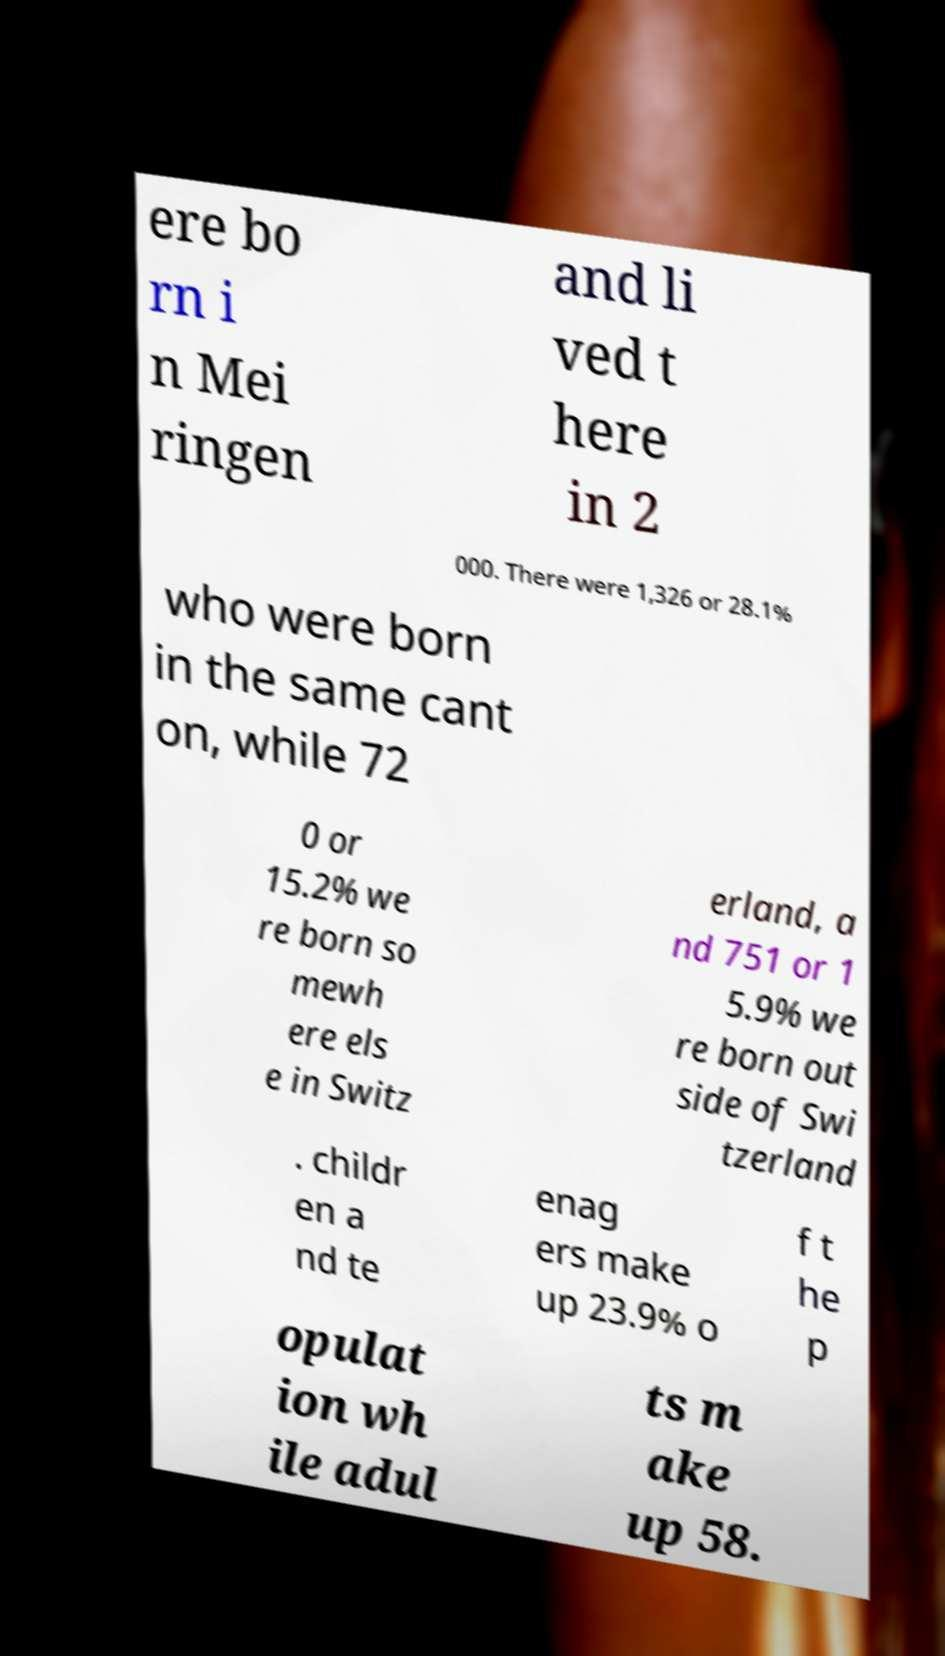What messages or text are displayed in this image? I need them in a readable, typed format. ere bo rn i n Mei ringen and li ved t here in 2 000. There were 1,326 or 28.1% who were born in the same cant on, while 72 0 or 15.2% we re born so mewh ere els e in Switz erland, a nd 751 or 1 5.9% we re born out side of Swi tzerland . childr en a nd te enag ers make up 23.9% o f t he p opulat ion wh ile adul ts m ake up 58. 